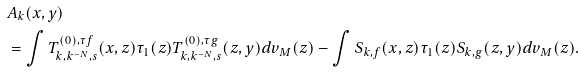<formula> <loc_0><loc_0><loc_500><loc_500>& A _ { k } ( x , y ) \\ & = \int T ^ { ( 0 ) , \tau f } _ { k , k ^ { - N } , s } ( x , z ) \tau _ { 1 } ( z ) T ^ { ( 0 ) , \tau g } _ { k , k ^ { - N } , s } ( z , y ) d v _ { M } ( z ) - \int S _ { k , f } ( x , z ) \tau _ { 1 } ( z ) S _ { k , g } ( z , y ) d v _ { M } ( z ) .</formula> 